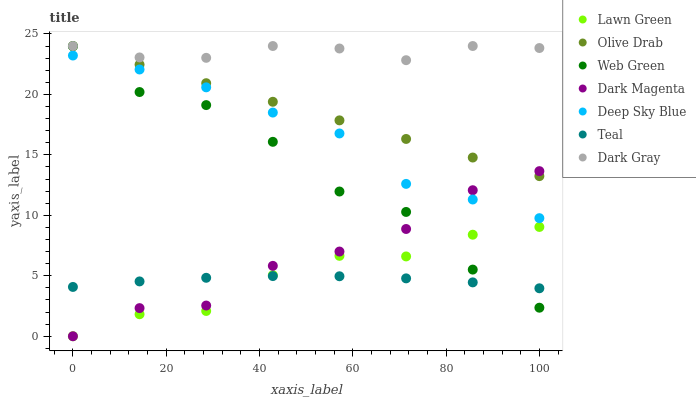Does Teal have the minimum area under the curve?
Answer yes or no. Yes. Does Dark Gray have the maximum area under the curve?
Answer yes or no. Yes. Does Deep Sky Blue have the minimum area under the curve?
Answer yes or no. No. Does Deep Sky Blue have the maximum area under the curve?
Answer yes or no. No. Is Olive Drab the smoothest?
Answer yes or no. Yes. Is Web Green the roughest?
Answer yes or no. Yes. Is Deep Sky Blue the smoothest?
Answer yes or no. No. Is Deep Sky Blue the roughest?
Answer yes or no. No. Does Lawn Green have the lowest value?
Answer yes or no. Yes. Does Deep Sky Blue have the lowest value?
Answer yes or no. No. Does Olive Drab have the highest value?
Answer yes or no. Yes. Does Deep Sky Blue have the highest value?
Answer yes or no. No. Is Lawn Green less than Olive Drab?
Answer yes or no. Yes. Is Dark Gray greater than Lawn Green?
Answer yes or no. Yes. Does Olive Drab intersect Dark Magenta?
Answer yes or no. Yes. Is Olive Drab less than Dark Magenta?
Answer yes or no. No. Is Olive Drab greater than Dark Magenta?
Answer yes or no. No. Does Lawn Green intersect Olive Drab?
Answer yes or no. No. 